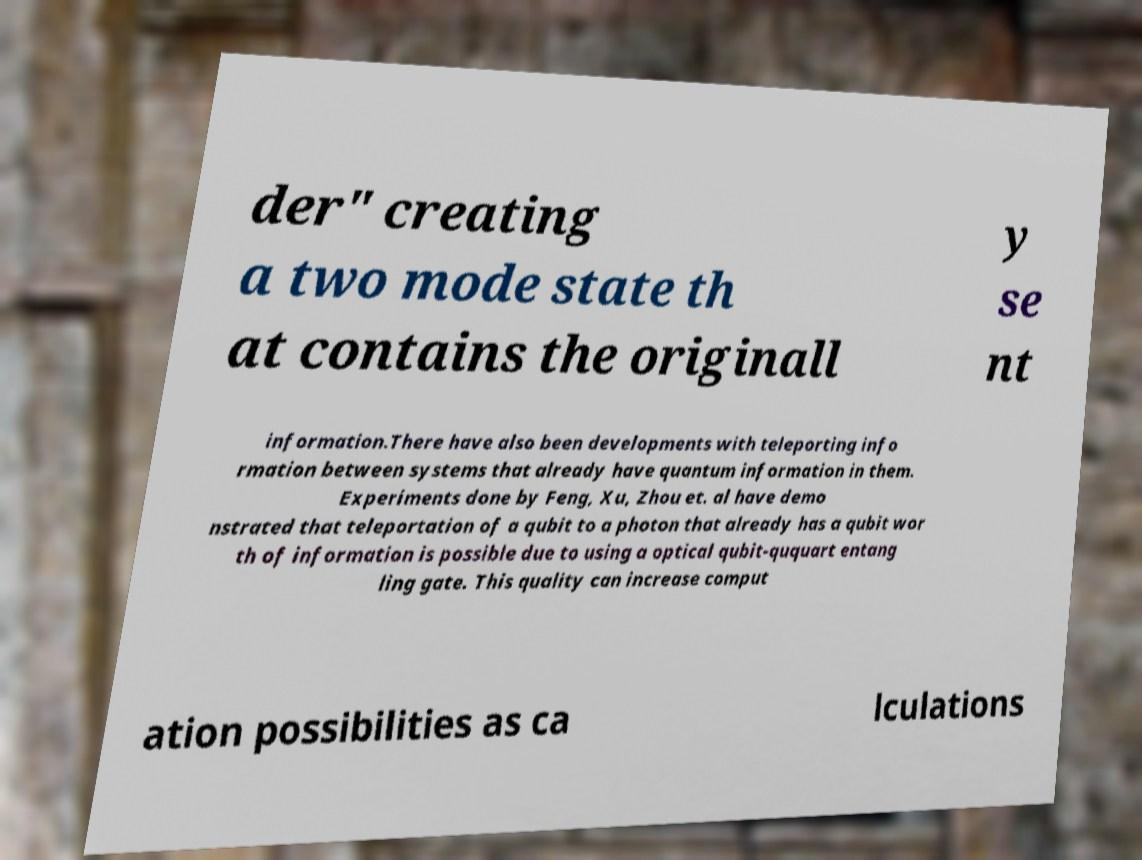Can you accurately transcribe the text from the provided image for me? der" creating a two mode state th at contains the originall y se nt information.There have also been developments with teleporting info rmation between systems that already have quantum information in them. Experiments done by Feng, Xu, Zhou et. al have demo nstrated that teleportation of a qubit to a photon that already has a qubit wor th of information is possible due to using a optical qubit-ququart entang ling gate. This quality can increase comput ation possibilities as ca lculations 